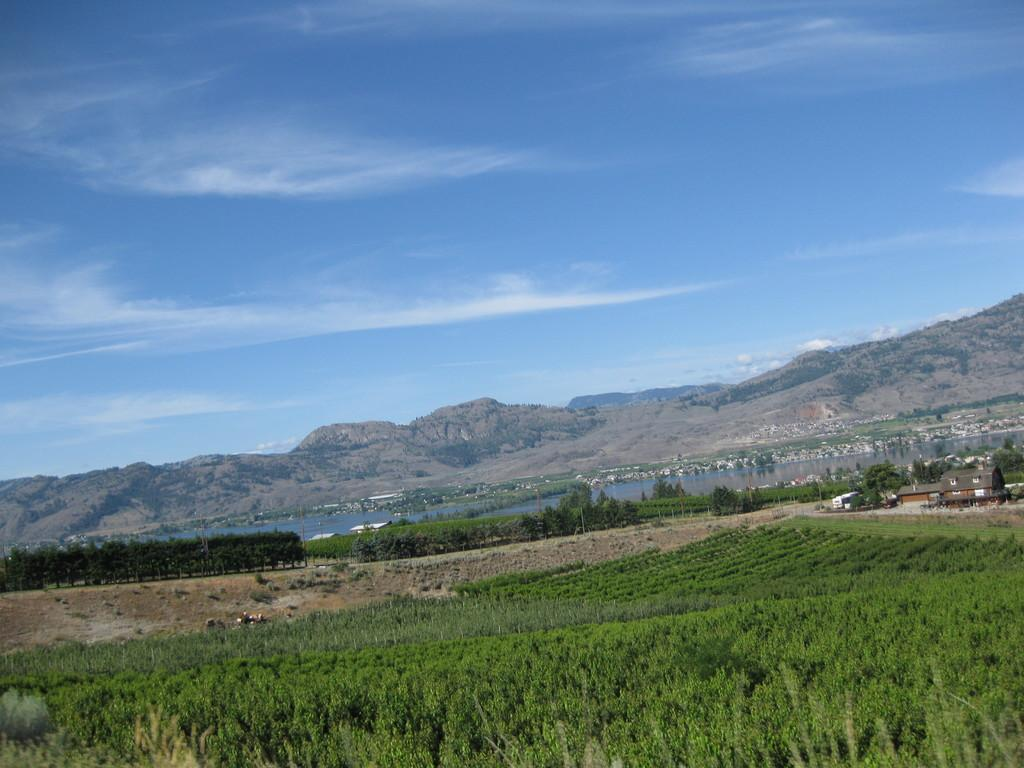What type of natural elements can be seen in the image? There are plants, trees, and a lake in the image. What type of man-made structures are present in the image? There are houses in the image. What can be seen in the background of the image? There are hills and the sky visible in the background. How many jellyfish are swimming in the lake in the image? There are no jellyfish present in the image; it features plants, trees, houses, hills, and the sky. What type of design is used for the houses in the image? The provided facts do not mention any specific design for the houses in the image. 